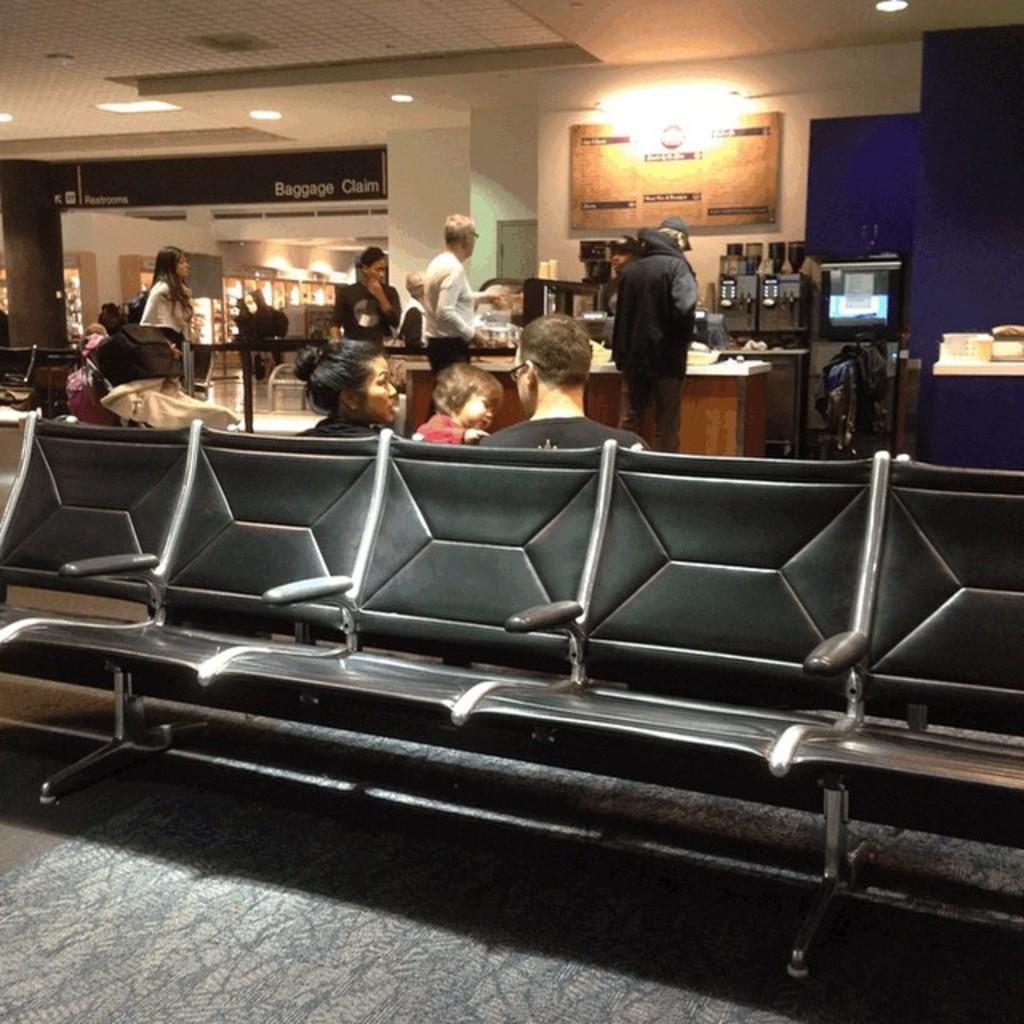What are the persons in the image doing? Some persons are sitting on chairs, while others are standing. Can you describe the lighting in the image? There is a light on top, which provides illumination. What objects can be seen on the table? There are machines on a table. What type of cart is being pulled by the hand in the image? There is no cart or hand present in the image. Can you see any steam coming from the machines in the image? The provided facts do not mention steam, so it cannot be determined if steam is present in the image. 